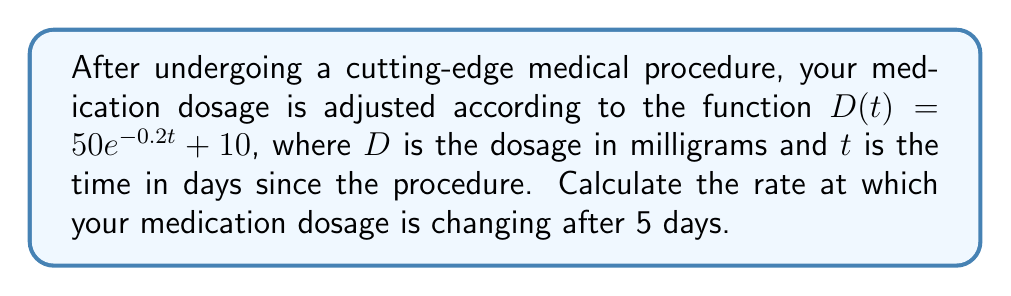Teach me how to tackle this problem. To find the rate of change of the medication dosage after 5 days, we need to calculate the derivative of the function $D(t)$ and evaluate it at $t=5$.

1. Given function: $D(t) = 50e^{-0.2t} + 10$

2. To find the rate of change, we need to differentiate $D(t)$ with respect to $t$:
   $$\frac{d}{dt}D(t) = \frac{d}{dt}(50e^{-0.2t} + 10)$$

3. Using the chain rule and the fact that the derivative of a constant is 0:
   $$\frac{d}{dt}D(t) = 50 \cdot \frac{d}{dt}(e^{-0.2t}) + 0$$

4. The derivative of $e^x$ is $e^x$, so:
   $$\frac{d}{dt}D(t) = 50 \cdot (-0.2)e^{-0.2t} = -10e^{-0.2t}$$

5. This gives us the rate of change function. To find the rate of change after 5 days, we evaluate this function at $t=5$:
   $$\frac{d}{dt}D(5) = -10e^{-0.2(5)} = -10e^{-1} \approx -3.679 \text{ mg/day}$$

The negative value indicates that the dosage is decreasing over time.
Answer: The rate of change of the medication dosage after 5 days is approximately -3.679 mg/day. 